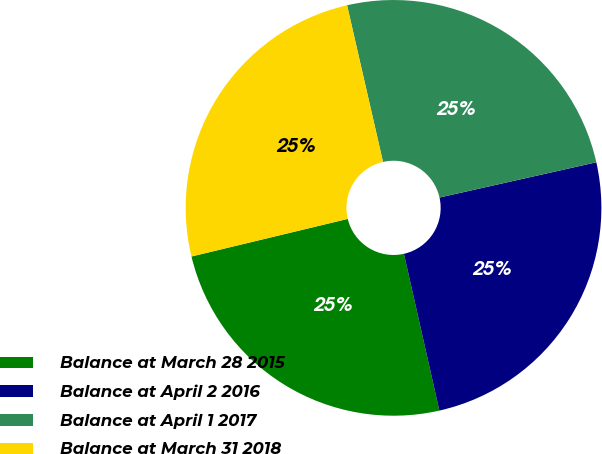Convert chart to OTSL. <chart><loc_0><loc_0><loc_500><loc_500><pie_chart><fcel>Balance at March 28 2015<fcel>Balance at April 2 2016<fcel>Balance at April 1 2017<fcel>Balance at March 31 2018<nl><fcel>24.78%<fcel>24.98%<fcel>25.07%<fcel>25.17%<nl></chart> 